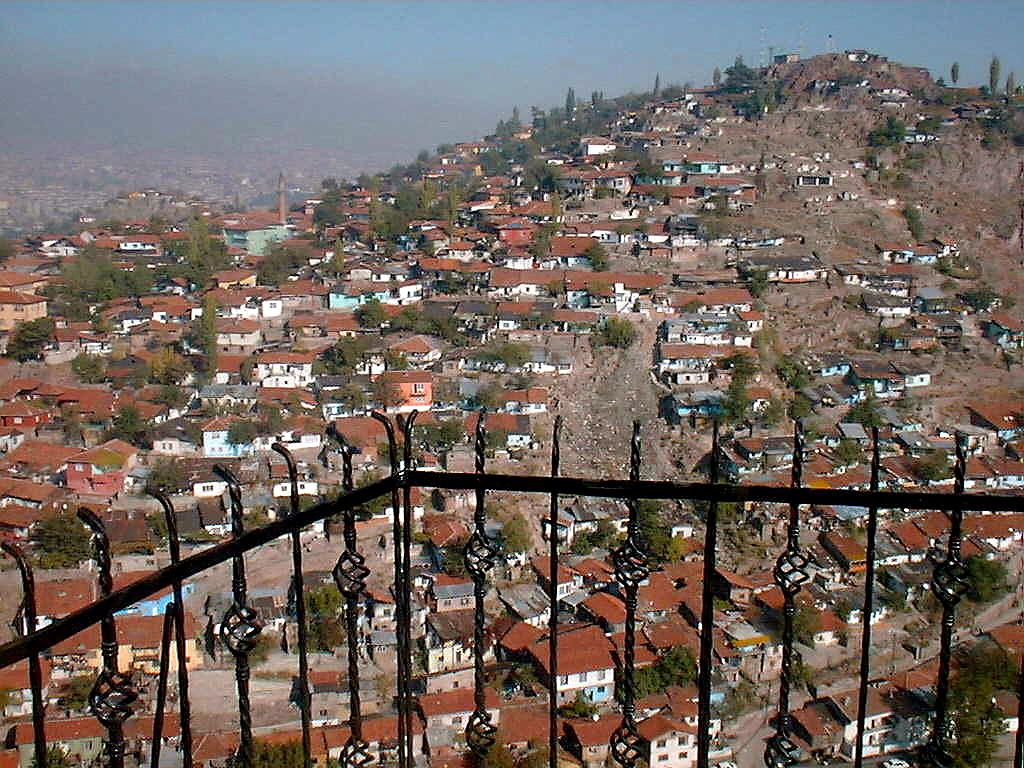What type of structures can be seen on the hill in the image? There are houses on a hill in the image. What other natural elements are present on the hill? There are trees on the hill in the image. What is visible at the top of the image? The sky is visible at the top of the image. What type of barrier is located at the bottom of the image? There is an iron grille at the bottom of the image. Can you see any insects helping to pick cherries in the image? There are no insects or cherries present in the image. 